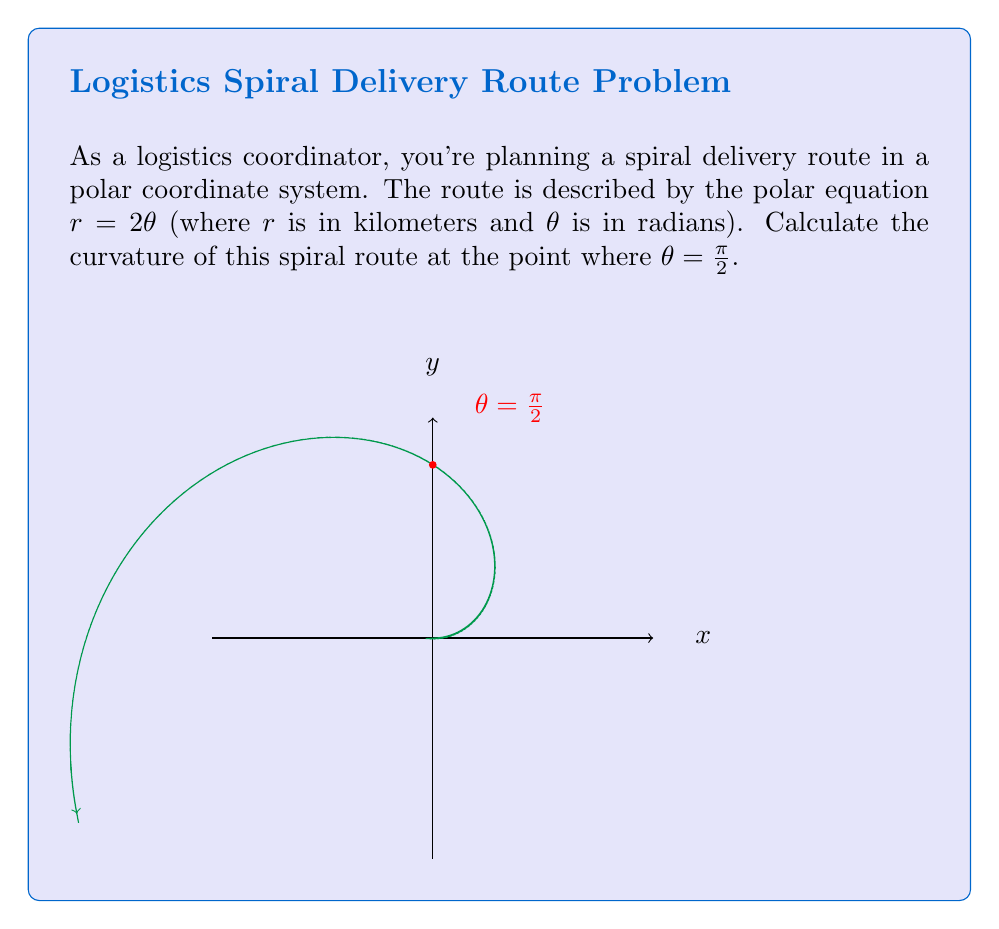Can you solve this math problem? To find the curvature of the spiral at $\theta = \frac{\pi}{2}$, we'll use the formula for curvature in polar coordinates:

$$\kappa = \frac{|r^2 + 2(r')^2 - rr''|}{(r^2 + (r')^2)^{3/2}}$$

where $r' = \frac{dr}{d\theta}$ and $r'' = \frac{d^2r}{d\theta^2}$.

Step 1: Find $r$, $r'$, and $r''$
$r = 2\theta$
$r' = \frac{dr}{d\theta} = 2$
$r'' = \frac{d^2r}{d\theta^2} = 0$

Step 2: Substitute $\theta = \frac{\pi}{2}$ into $r$
$r = 2(\frac{\pi}{2}) = \pi$

Step 3: Substitute all values into the curvature formula
$$\kappa = \frac{|(\pi)^2 + 2(2)^2 - \pi(0)|}{(\pi^2 + 2^2)^{3/2}}$$

Step 4: Simplify
$$\kappa = \frac{|\pi^2 + 8|}{(\pi^2 + 4)^{3/2}}$$

Step 5: Calculate the final value
$$\kappa \approx 0.2806 \text{ km}^{-1}$$
Answer: $0.2806 \text{ km}^{-1}$ 